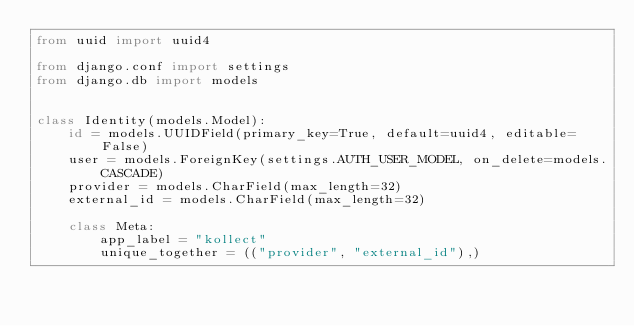<code> <loc_0><loc_0><loc_500><loc_500><_Python_>from uuid import uuid4

from django.conf import settings
from django.db import models


class Identity(models.Model):
    id = models.UUIDField(primary_key=True, default=uuid4, editable=False)
    user = models.ForeignKey(settings.AUTH_USER_MODEL, on_delete=models.CASCADE)
    provider = models.CharField(max_length=32)
    external_id = models.CharField(max_length=32)

    class Meta:
        app_label = "kollect"
        unique_together = (("provider", "external_id"),)
</code> 